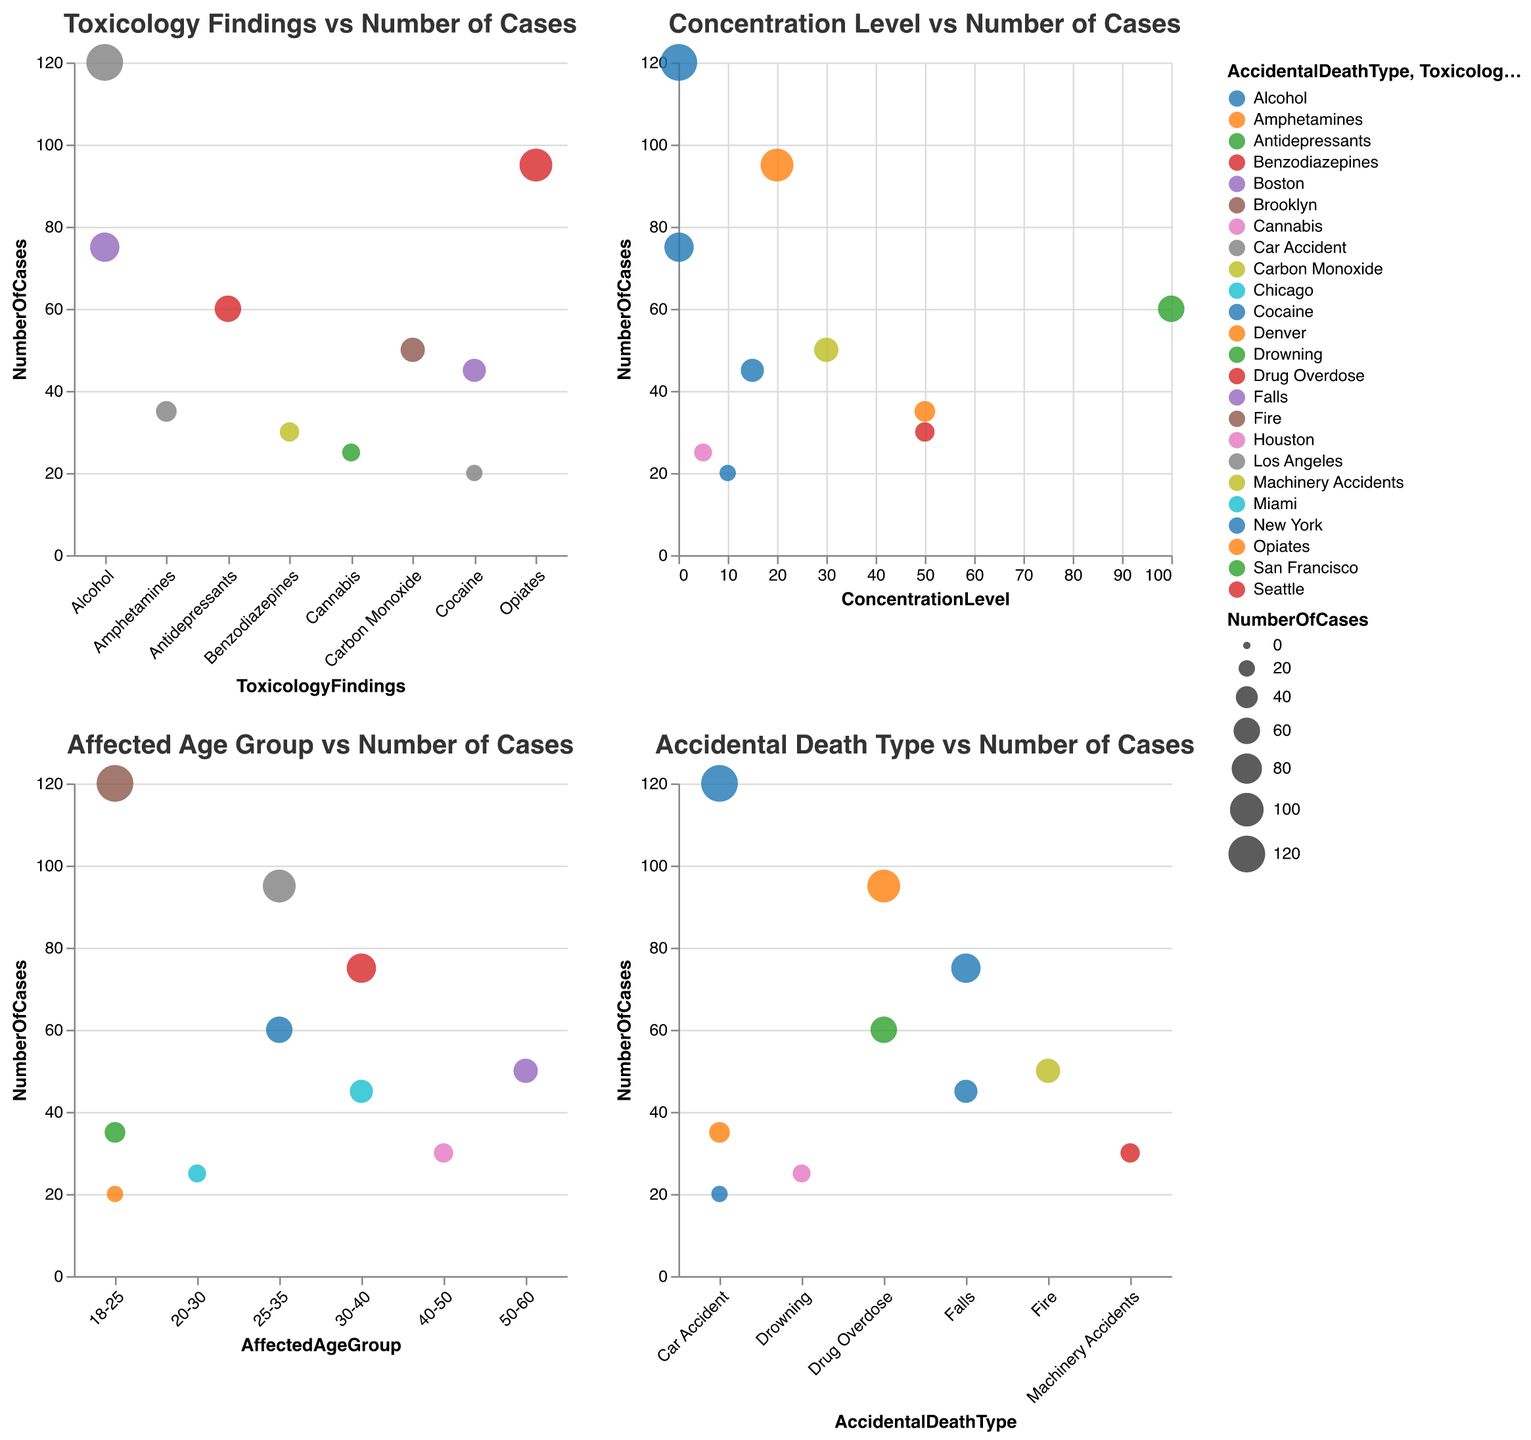What's the title of the first chart? The first chart's title is displayed at the top of the chart. It reads "Toxicology Findings vs Number of Cases."
Answer: Toxicology Findings vs Number of Cases Which type of accidental death has the highest number of cases related to alcohol in the first chart? In the first chart, the circle representing Alcohol and Car Accident has the largest size, indicating it has the highest number of cases (120).
Answer: Car Accident What is the concentration level of Carbon Monoxide in cases of fire-related accidental deaths? In the second chart, the concentration level for Carbon Monoxide associated with Fire can be determined from the tooltip information. It is 30% COHb.
Answer: 30% COHb Which age group has the highest number of cases involving alcohol? In the third chart, we look at the age groups for alcohol-related incidents. The circle under 18-25 and Car Accident has the largest size (120 cases), representing the highest number.
Answer: 18-25 Compare the number of drug overdose cases related to opiates vs. antidepressants. Looking at the first chart, compare the sizes of the circles for Opiates and Drug Overdose (95 cases) and Antidepressants and Drug Overdose (60 cases). The former is larger, implying more cases.
Answer: Opiates have more cases How many unique types of accidental deaths involve Cocaine? Cocaine appears in two distinct death types: Falls and Car Accident. This can be verified by counting the different circles labeled with Cocaine in the first chart.
Answer: Two What is the relationship between the concentration level and the number of cases for alcohol? The second chart shows two data points for Alcohol. One for 0.08 concentration and another for 0.12 concentration. The data points indicate 120 and 75 cases, respectively. Higher concentration shows slightly fewer cases.
Answer: Higher concentration, slightly fewer cases Is there a specific location that appears frequently across all charts? By checking the tooltip information across all subplots, we can see that locations appear multiple times. However, cities like Brooklyn and Seattle appear frequently.
Answer: Brooklyn and Seattle What's the correlation between the affected age group and the number of cases for car accidents? In the third chart, for Car Accidents, the age group with most cases is 18-25, as shown by the largest circle for this age group. There are fewer cases in other age groups.
Answer: Most cases in 18-25 age group What is the unique color scheme used for representing different accidental death types? By observing the first chart, different colors represent different accidental death types. This visual distinction helps differentiate the types without coding knowledge.
Answer: Varies by death type (e.g., Car Accidents, Drug Overdose, etc.) 